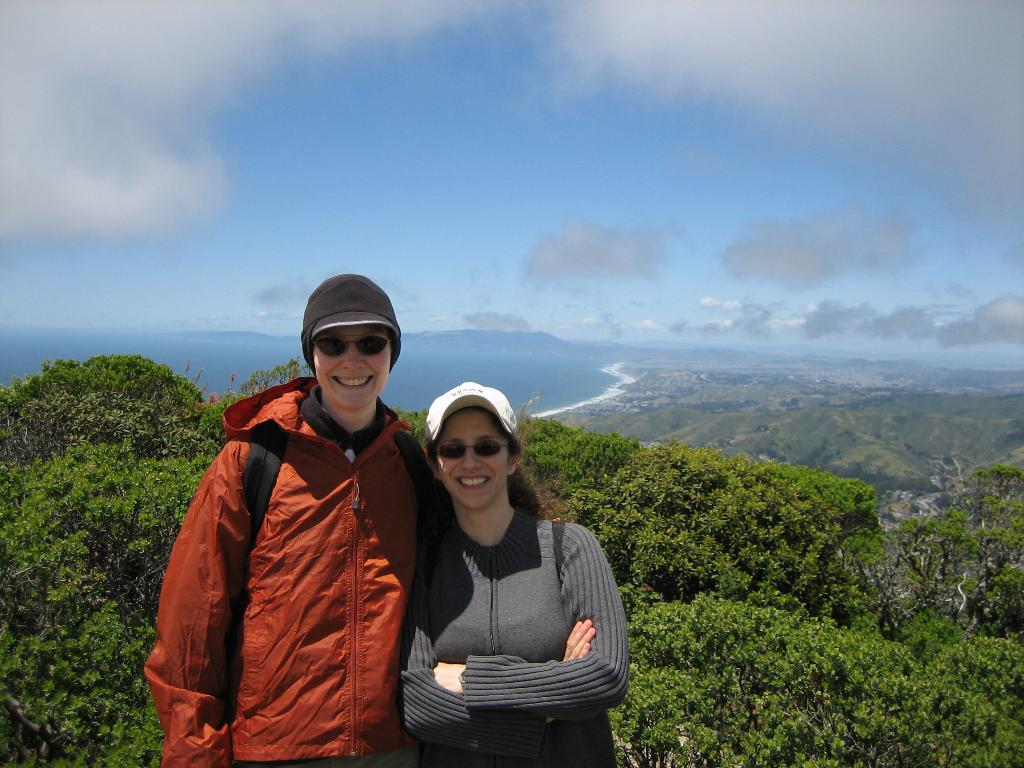How many people are in the image? There are two people in the image, a man and a woman. What are the man and woman doing in the image? Both the man and woman are standing and smiling. What can be seen in the background of the image? There is a tree in the image, and the sky is blue and cloudy. Reasoning: Let' Let's think step by step in order to produce the conversation. We start by identifying the number of people in the image, which is two. Then, we describe their actions and expressions, noting that they are both standing and smiling. Next, we mention the background elements, including the tree and the sky. Each question is designed to elicit a specific detail about the image that is known from the provided facts. Absurd Question/Answer: What type of key is the woman holding in the image? There is no key present in the image; the woman is not holding anything. How many birds are visible in the image? There are no birds visible in the image. What type of bird is perched on the man's shoulder in the image? There are no birds visible in the image, and no bird is perched on the man's shoulder. 